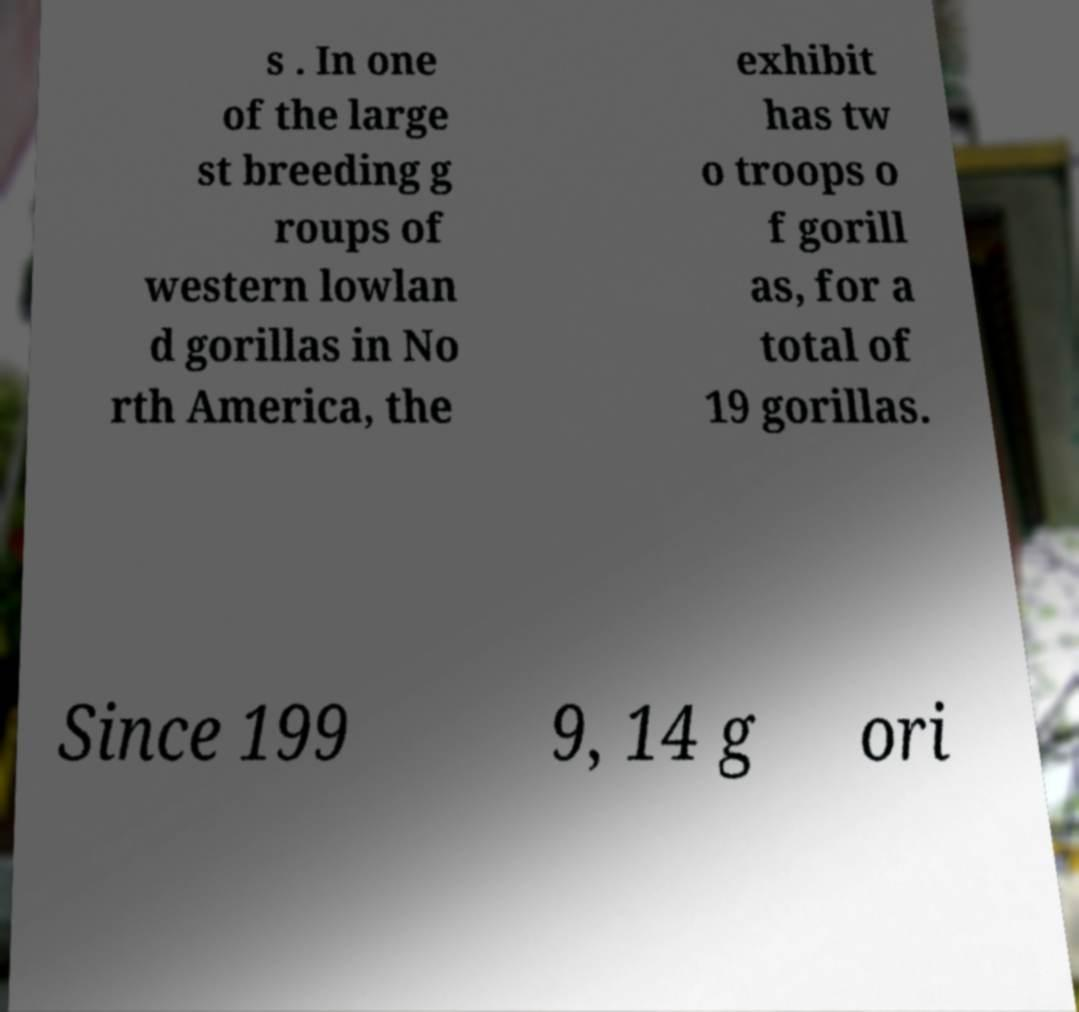Please identify and transcribe the text found in this image. s . In one of the large st breeding g roups of western lowlan d gorillas in No rth America, the exhibit has tw o troops o f gorill as, for a total of 19 gorillas. Since 199 9, 14 g ori 